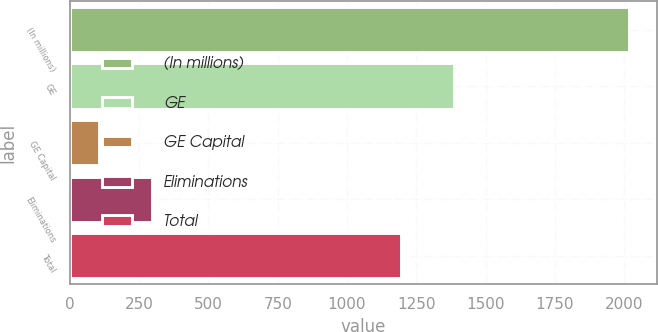Convert chart to OTSL. <chart><loc_0><loc_0><loc_500><loc_500><bar_chart><fcel>(In millions)<fcel>GE<fcel>GE Capital<fcel>Eliminations<fcel>Total<nl><fcel>2015<fcel>1386.8<fcel>107<fcel>297.8<fcel>1196<nl></chart> 